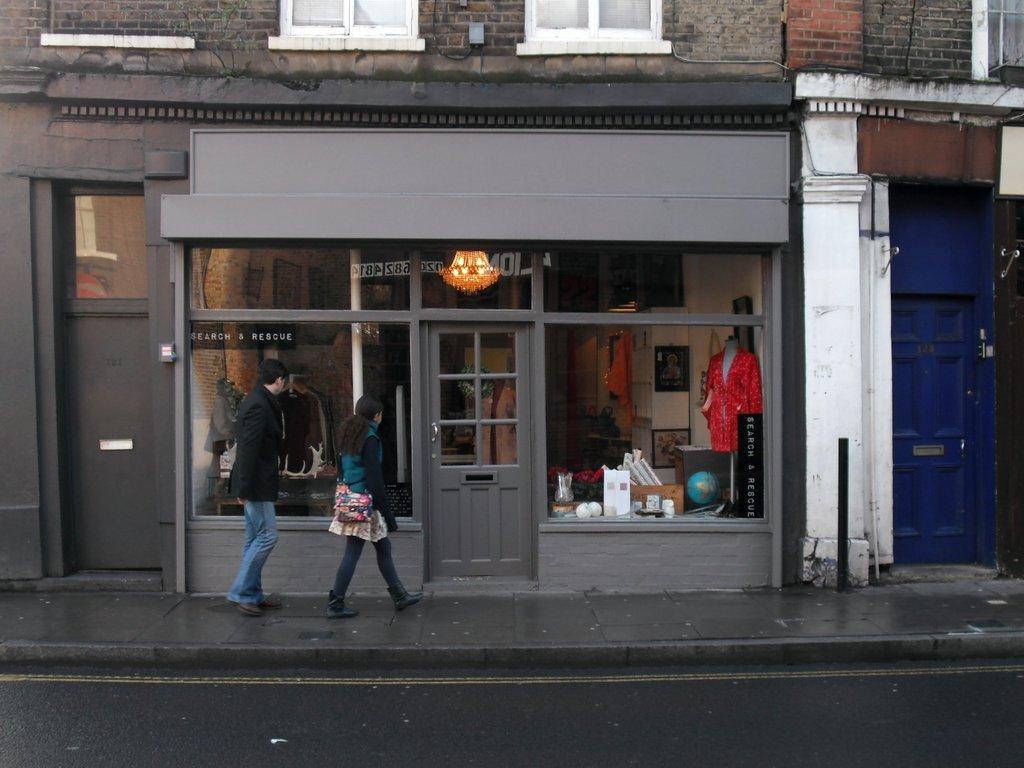Please provide a concise description of this image. In this image there is a road, beside the road there is a footpath on that footpath a men and women are walking,in the background there is shop that shop has glass doors. 